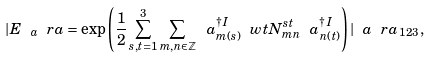<formula> <loc_0><loc_0><loc_500><loc_500>| E _ { \ a } \ r a = \exp \left ( \frac { 1 } { 2 } \sum _ { s , t = 1 } ^ { 3 } \sum _ { m , n \in \mathbb { Z } } \ a ^ { \dag \, I } _ { m ( s ) } \ w t { N } ^ { s t } _ { m n } \ a ^ { \dag \, I } _ { n ( t ) } \right ) | \ a \ r a _ { 1 2 3 } \, ,</formula> 